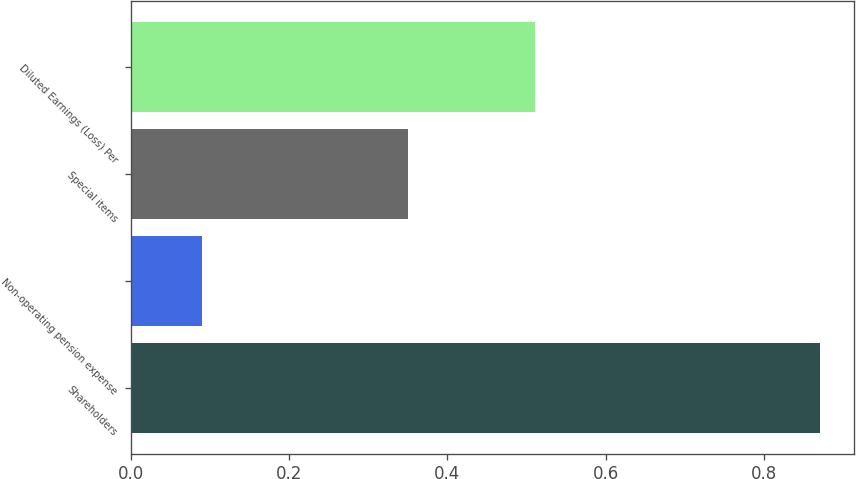<chart> <loc_0><loc_0><loc_500><loc_500><bar_chart><fcel>Shareholders<fcel>Non-operating pension expense<fcel>Special items<fcel>Diluted Earnings (Loss) Per<nl><fcel>0.87<fcel>0.09<fcel>0.35<fcel>0.51<nl></chart> 